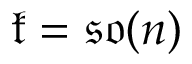<formula> <loc_0><loc_0><loc_500><loc_500>{ \mathfrak { k } } = { \mathfrak { s o } } ( n )</formula> 